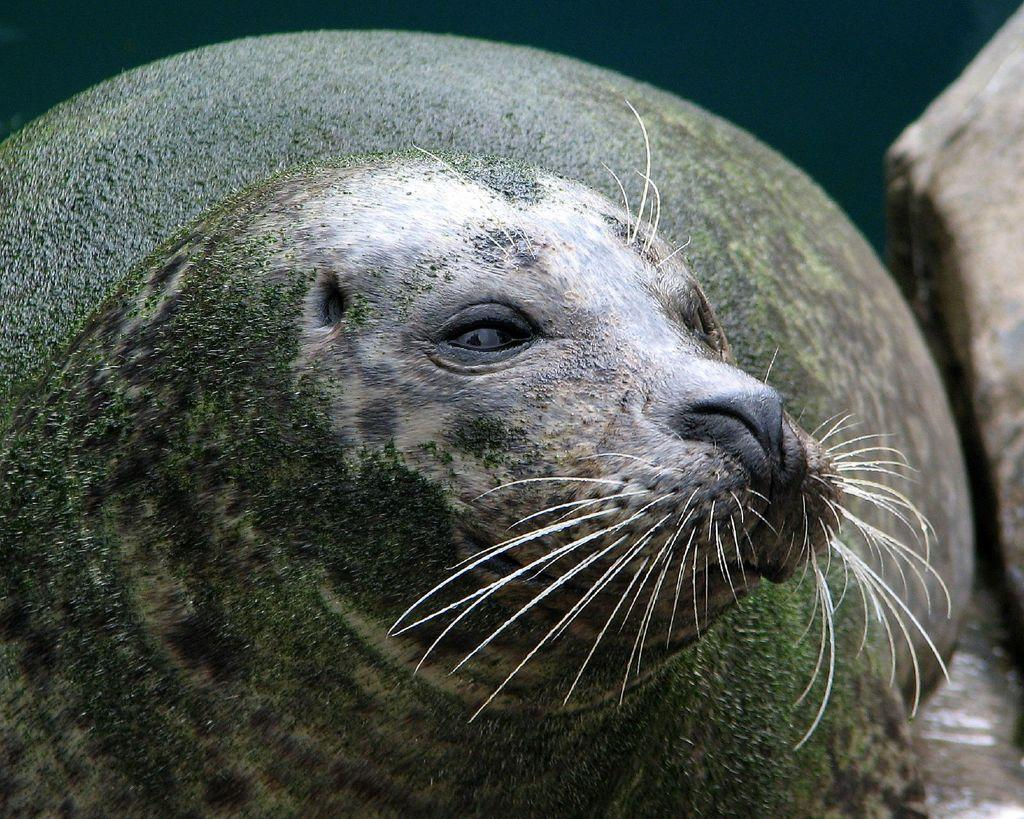What animal is the main subject of the image? There is a seal in the image. What can be seen on the seal's body? The seal has a green color thing on its body. What type of observation can be made about the seal's laughter in the image? There is no indication of the seal laughing in the image, and therefore no such observation can be made. 